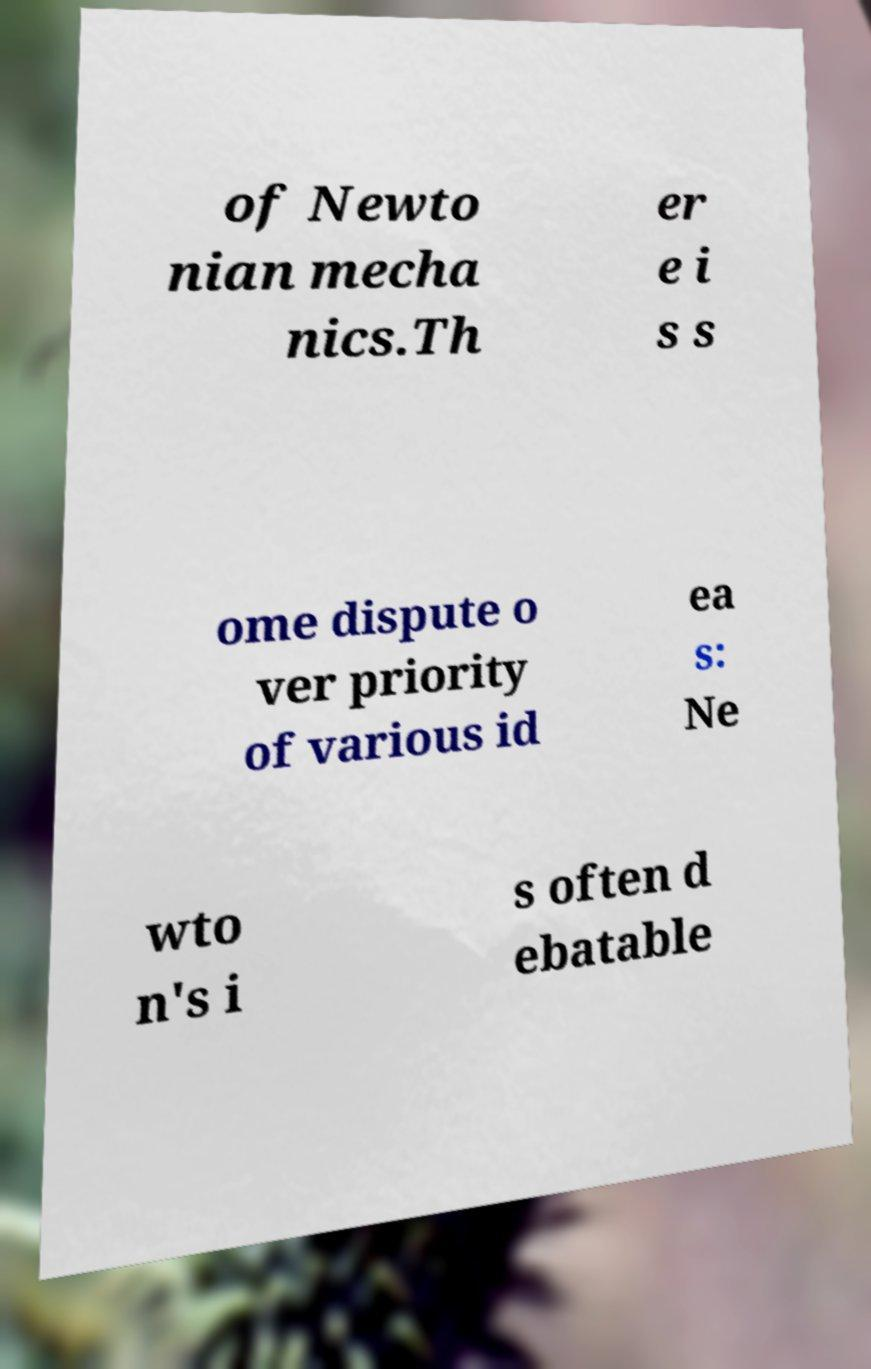There's text embedded in this image that I need extracted. Can you transcribe it verbatim? of Newto nian mecha nics.Th er e i s s ome dispute o ver priority of various id ea s: Ne wto n's i s often d ebatable 